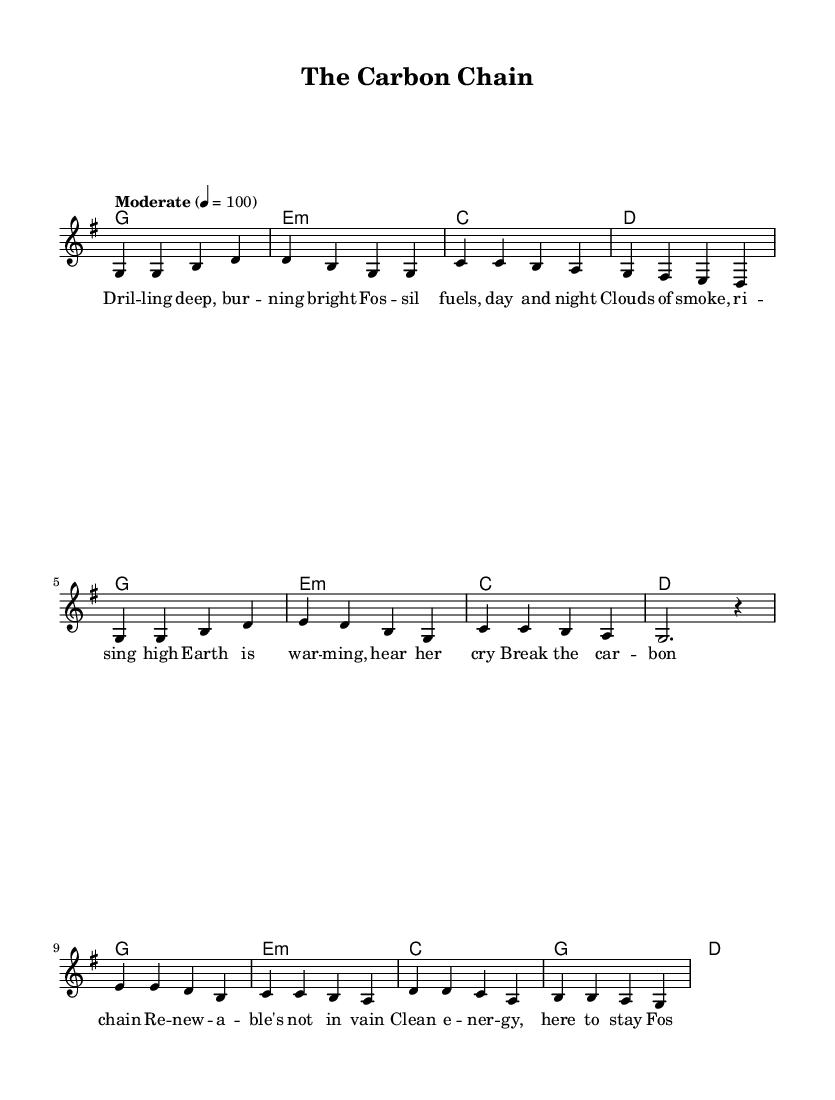What is the key signature of this music? The key signature indicates the notes that are sharpened or flattened. In the notation, there are no sharps or flats shown, which means it is in G major.
Answer: G major What is the time signature of this music? The time signature is represented at the beginning of the score. Here, it is written as 4/4, meaning there are four beats in each measure.
Answer: 4/4 What is the tempo marking for this piece? The tempo marking indicates the speed of the piece. It is written as "Moderate" with a quarter note = 100 beats per minute.
Answer: Moderate How many verses are there in this song? By analyzing the structure of the lyrics, there is one verse, followed by a chorus and bridge, suggesting a simple folk song format.
Answer: One What is the main theme addressed in the lyrics? The lyrics highlight environmental concerns tied to fossil fuel use, indicating a message about renewable energy and climate action.
Answer: Renewable energy Which instruments are used in this piece based on the score? The score specifically displays a staff for voice and chord names, implying that it is primarily for vocal performance, often with accompaniment from guitar or piano.
Answer: Voice and Chords What does the bridge section refer to in the overall structure? A bridge in music often serves as a contrasting section that typically provides a different perspective or theme. Here, it shifts focus to the benefits of renewable energy sources like sun and wind.
Answer: A contrasting theme 